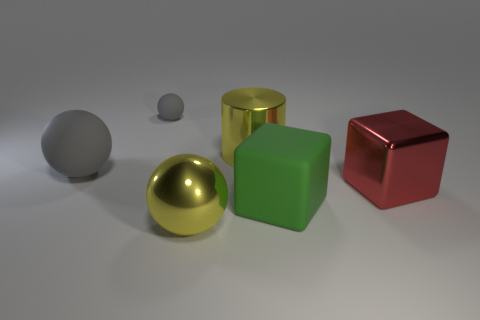Add 2 yellow metallic spheres. How many objects exist? 8 Subtract all cylinders. How many objects are left? 5 Add 3 big gray matte objects. How many big gray matte objects are left? 4 Add 1 yellow metallic cylinders. How many yellow metallic cylinders exist? 2 Subtract 0 brown balls. How many objects are left? 6 Subtract all matte things. Subtract all brown spheres. How many objects are left? 3 